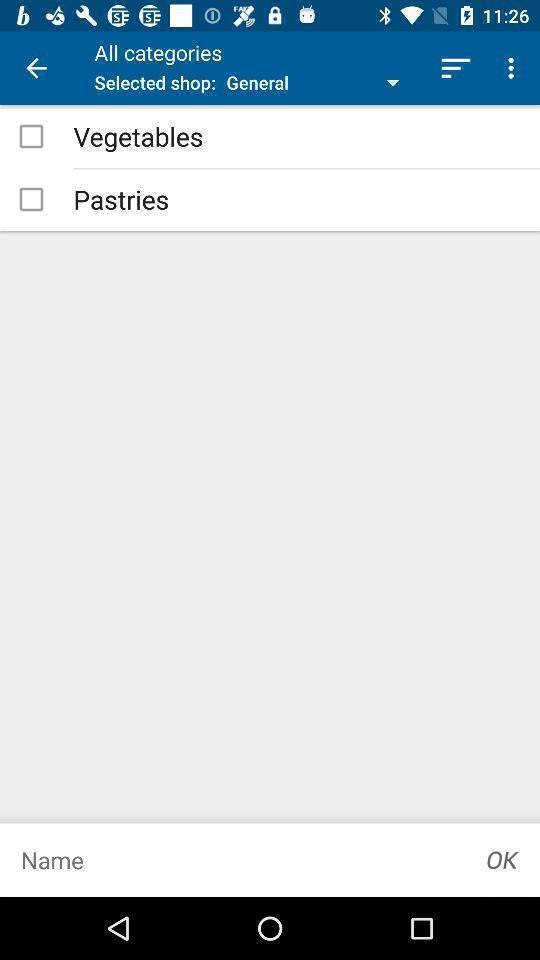Give me a narrative description of this picture. Screen showing categories. 